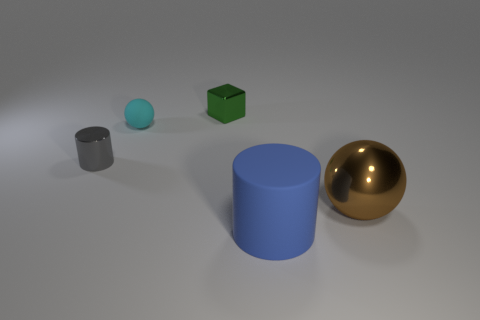What is the material of the small gray cylinder?
Offer a very short reply. Metal. What number of big objects are either yellow objects or gray metallic objects?
Provide a short and direct response. 0. What is the size of the other shiny thing that is the same shape as the small cyan thing?
Keep it short and to the point. Large. The cylinder in front of the thing left of the small cyan sphere is made of what material?
Your response must be concise. Rubber. How many matte objects are either balls or big spheres?
Keep it short and to the point. 1. What is the color of the metallic thing that is the same shape as the big matte thing?
Your answer should be very brief. Gray. There is a matte object that is in front of the brown shiny thing; is there a tiny object that is in front of it?
Provide a succinct answer. No. What number of metal objects are both left of the large brown shiny sphere and to the right of the rubber ball?
Your answer should be compact. 1. How many small green blocks are the same material as the big blue object?
Give a very brief answer. 0. What size is the matte object on the left side of the tiny metal object right of the matte ball?
Make the answer very short. Small. 